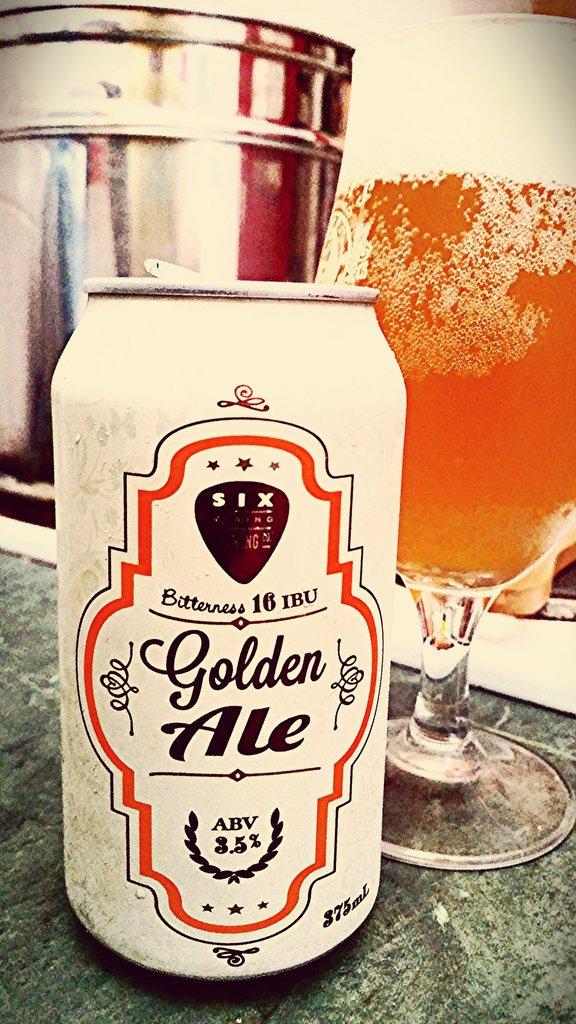How many abv is this beer?
Your answer should be very brief. 3.5%. 